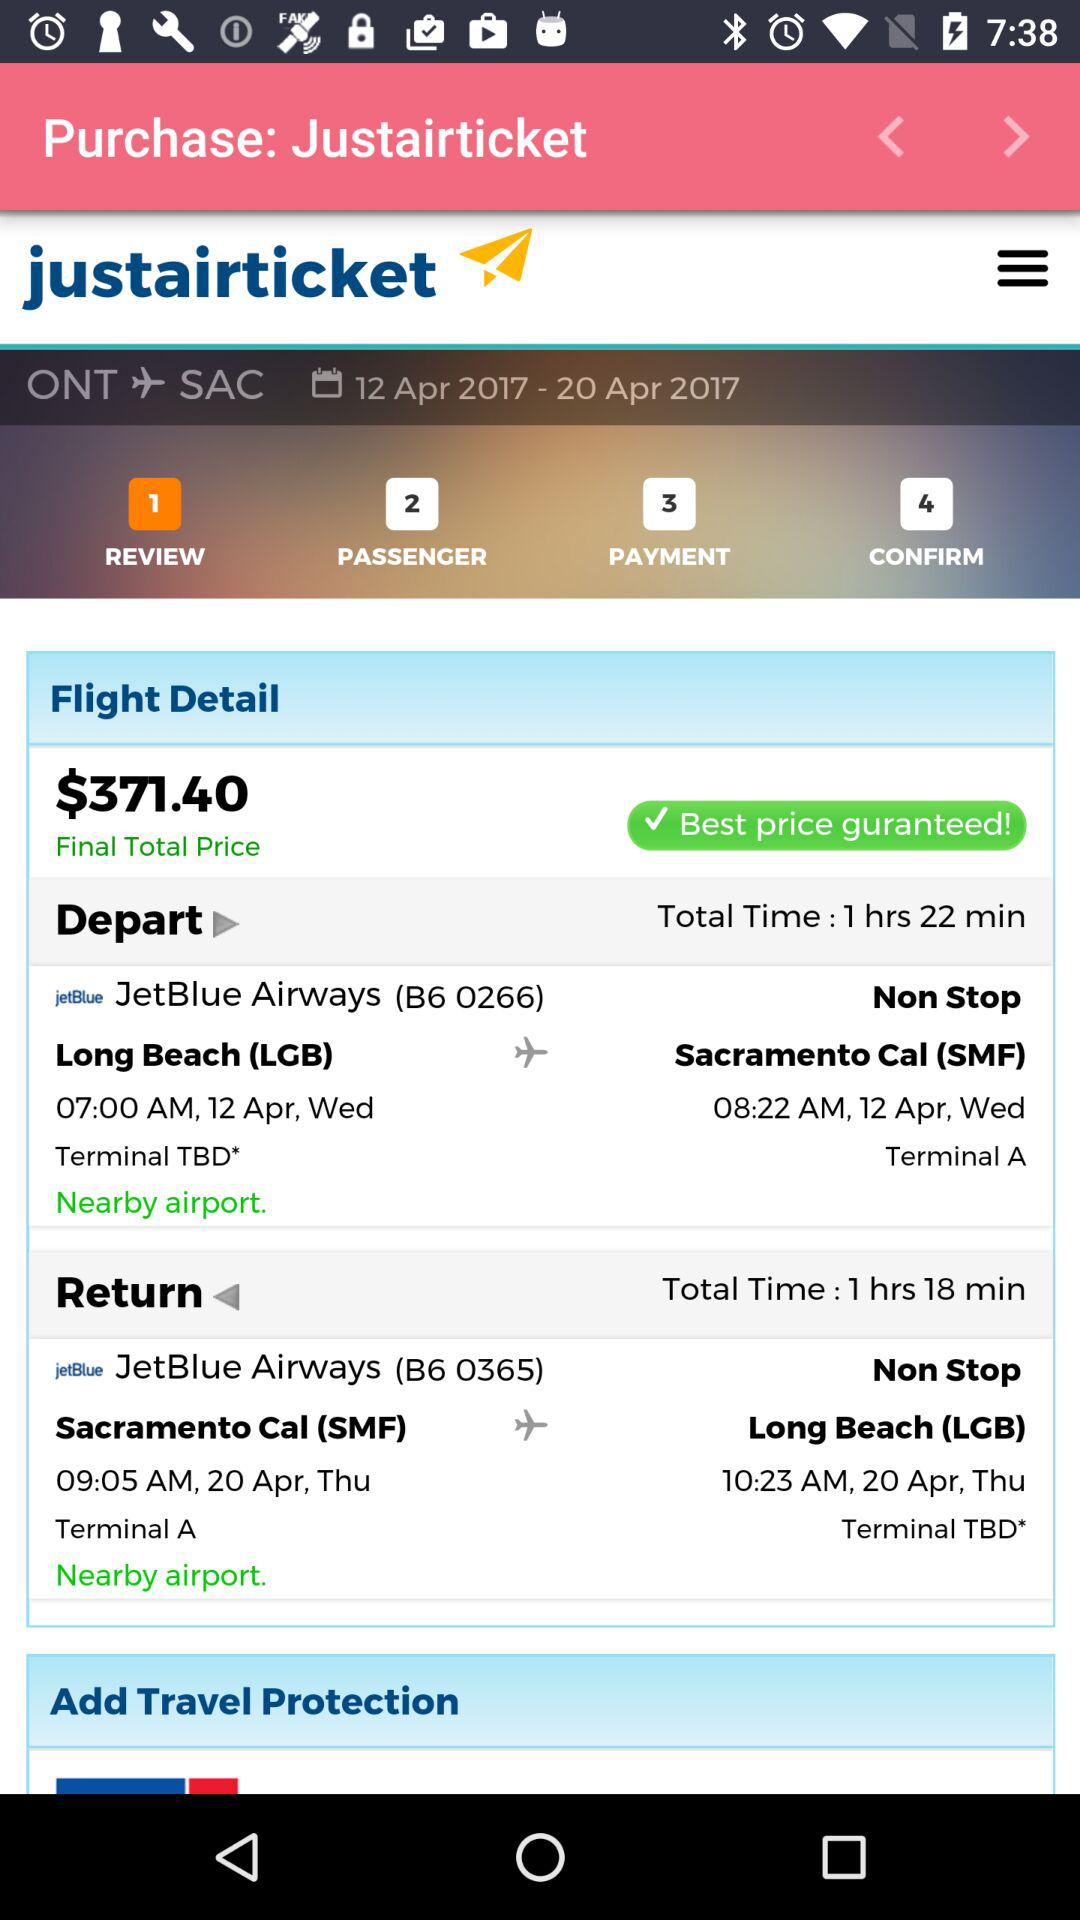What is the departure time for JetBlue Airways (B6 0266)? The departure time for JetBlue Airways (B6 0266) is 07:00 AM. 